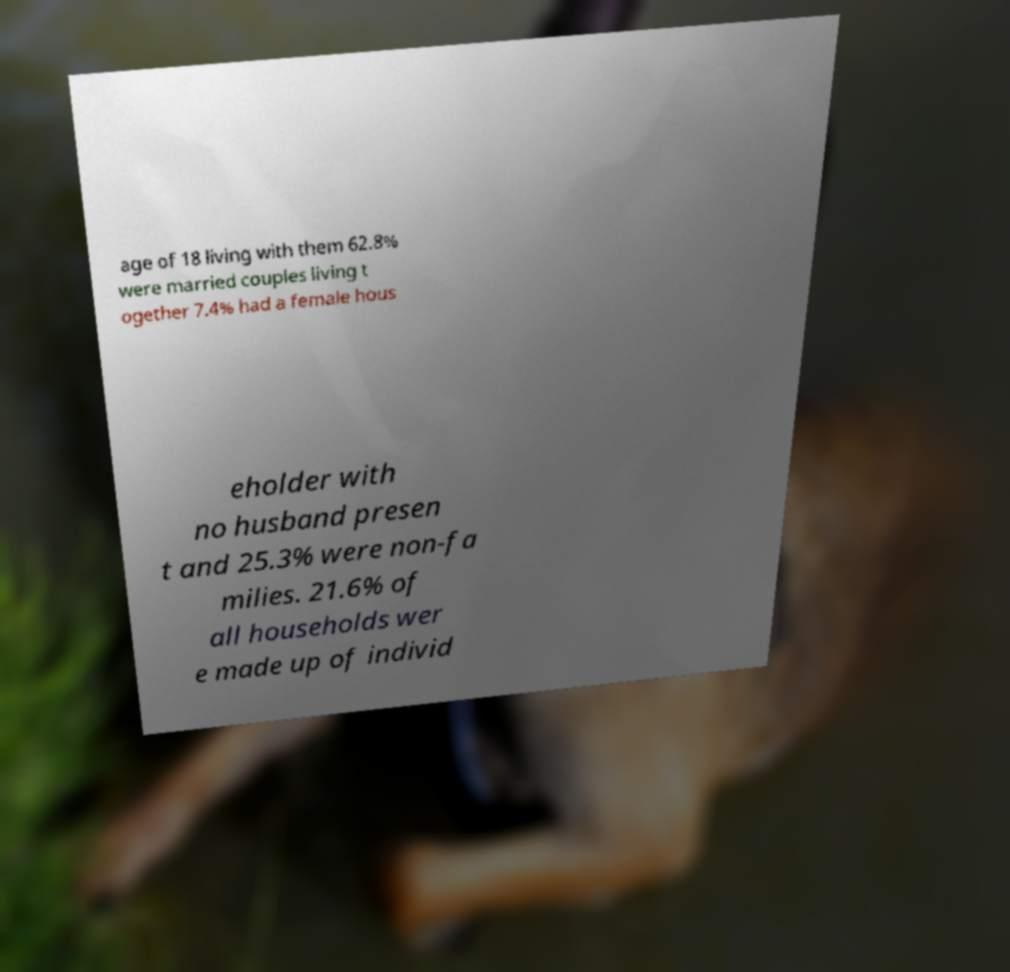Please identify and transcribe the text found in this image. age of 18 living with them 62.8% were married couples living t ogether 7.4% had a female hous eholder with no husband presen t and 25.3% were non-fa milies. 21.6% of all households wer e made up of individ 